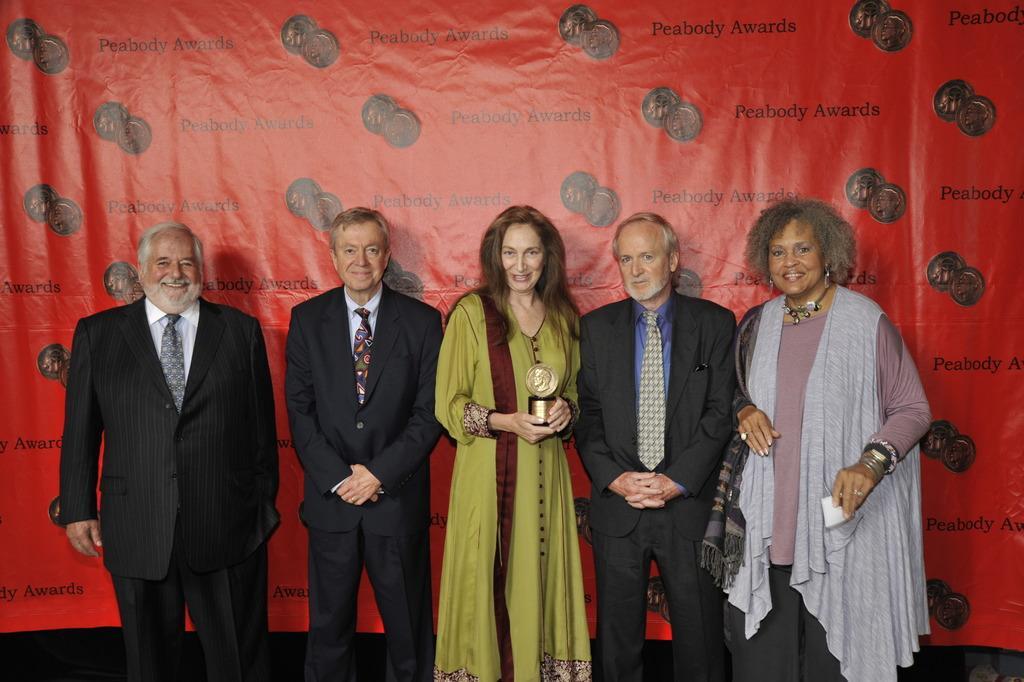In one or two sentences, can you explain what this image depicts? In this image, we can see there are three men in suits and two women in different color dresses, smiling and standing. One of them is holding a memento. In the background, there is an orange color banner. 